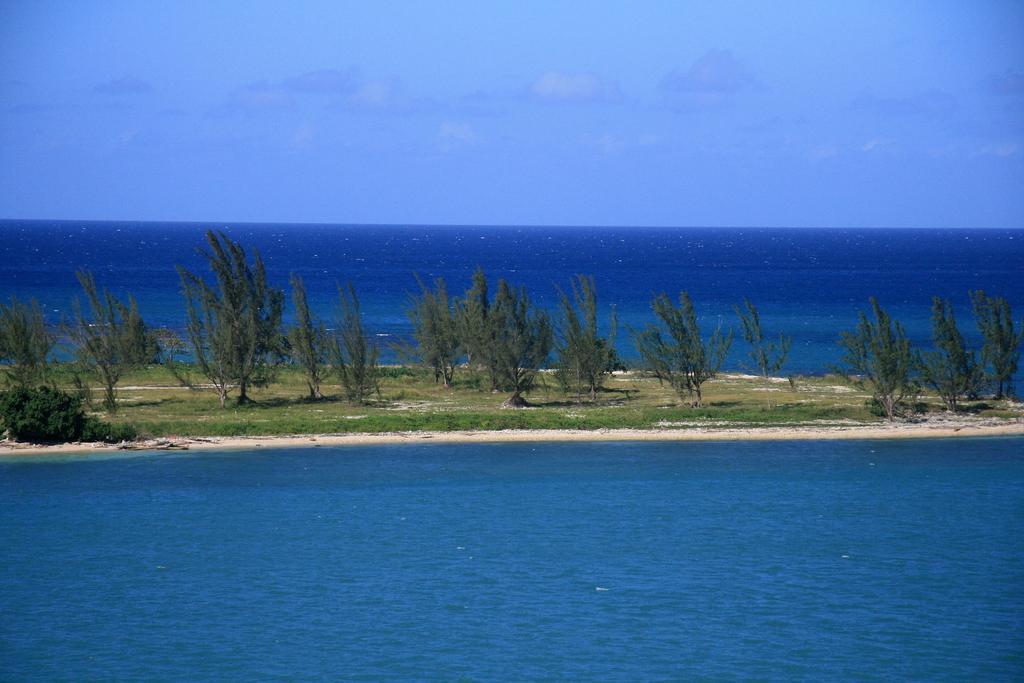Describe this image in one or two sentences. In this image, we can see trees and in the background, there is water. At the top, there is sky. 